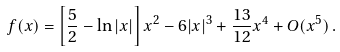Convert formula to latex. <formula><loc_0><loc_0><loc_500><loc_500>f ( x ) = \left [ \frac { 5 } { 2 } - \ln | x | \right ] x ^ { 2 } - 6 | x | ^ { 3 } + \frac { 1 3 } { 1 2 } x ^ { 4 } + O ( x ^ { 5 } ) \, .</formula> 